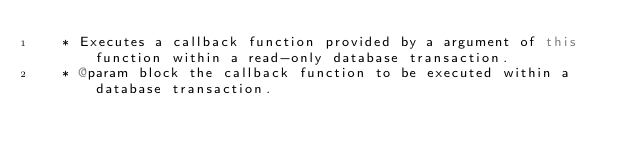<code> <loc_0><loc_0><loc_500><loc_500><_Scala_>   * Executes a callback function provided by a argument of this function within a read-only database transaction.
   * @param block the callback function to be executed within a database transaction.</code> 